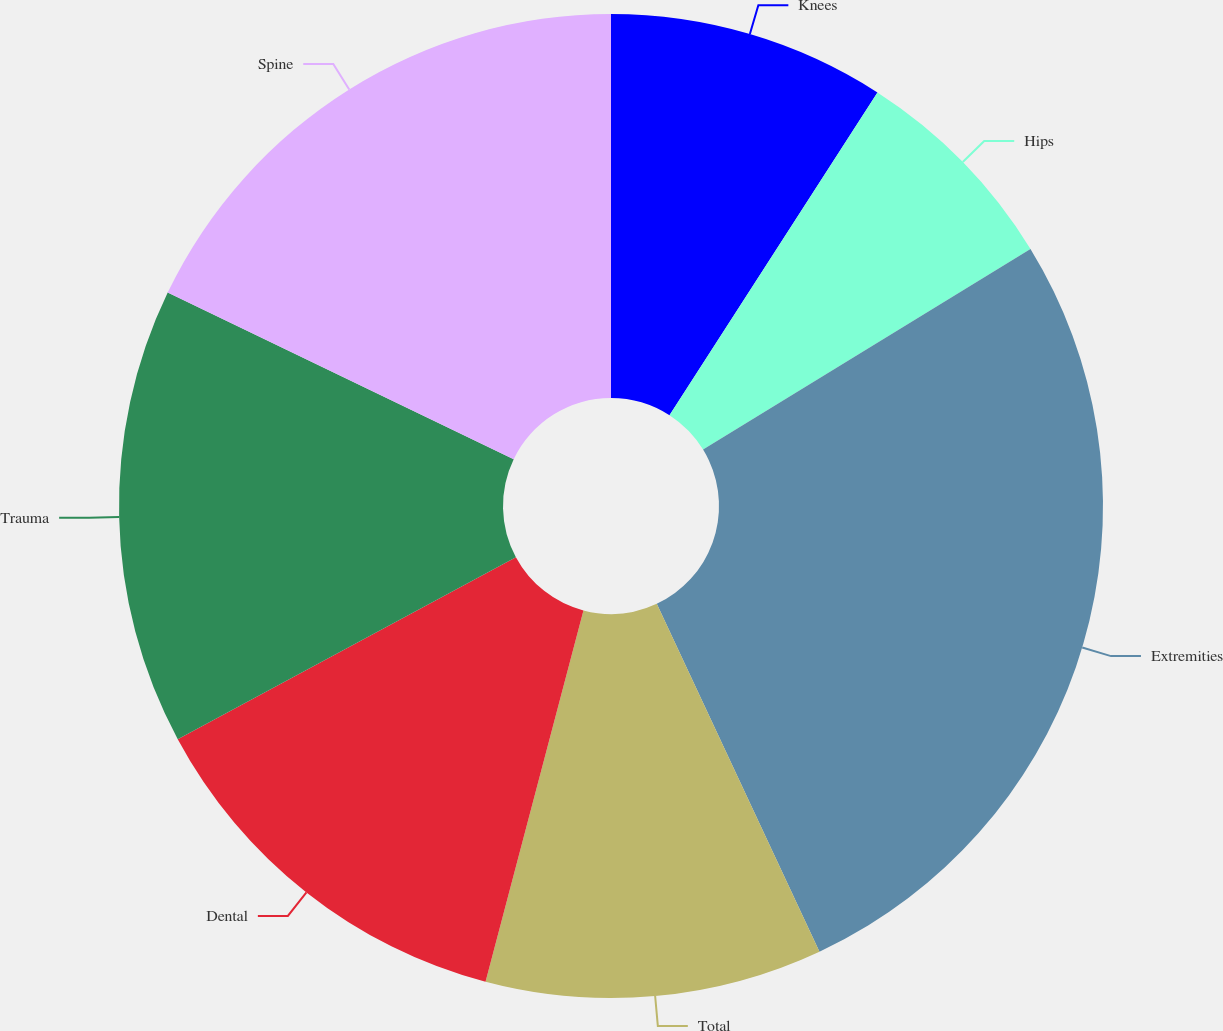Convert chart. <chart><loc_0><loc_0><loc_500><loc_500><pie_chart><fcel>Knees<fcel>Hips<fcel>Extremities<fcel>Total<fcel>Dental<fcel>Trauma<fcel>Spine<nl><fcel>9.11%<fcel>7.14%<fcel>26.79%<fcel>11.07%<fcel>13.04%<fcel>15.0%<fcel>17.86%<nl></chart> 